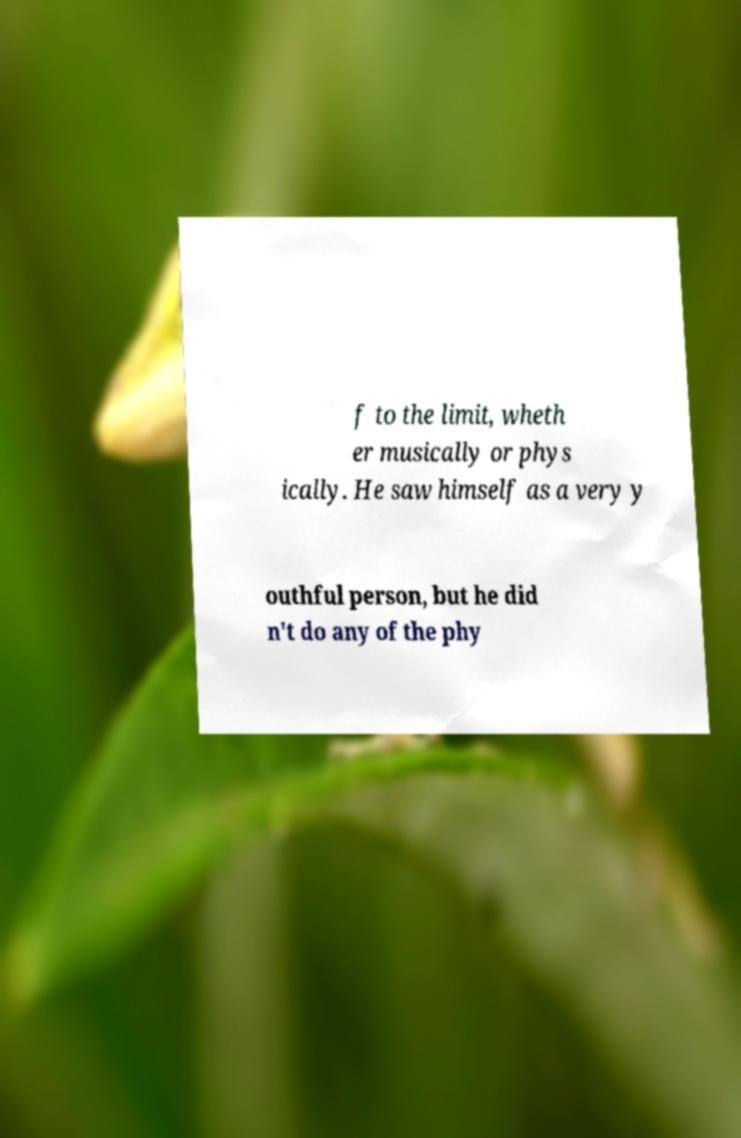Could you assist in decoding the text presented in this image and type it out clearly? f to the limit, wheth er musically or phys ically. He saw himself as a very y outhful person, but he did n't do any of the phy 